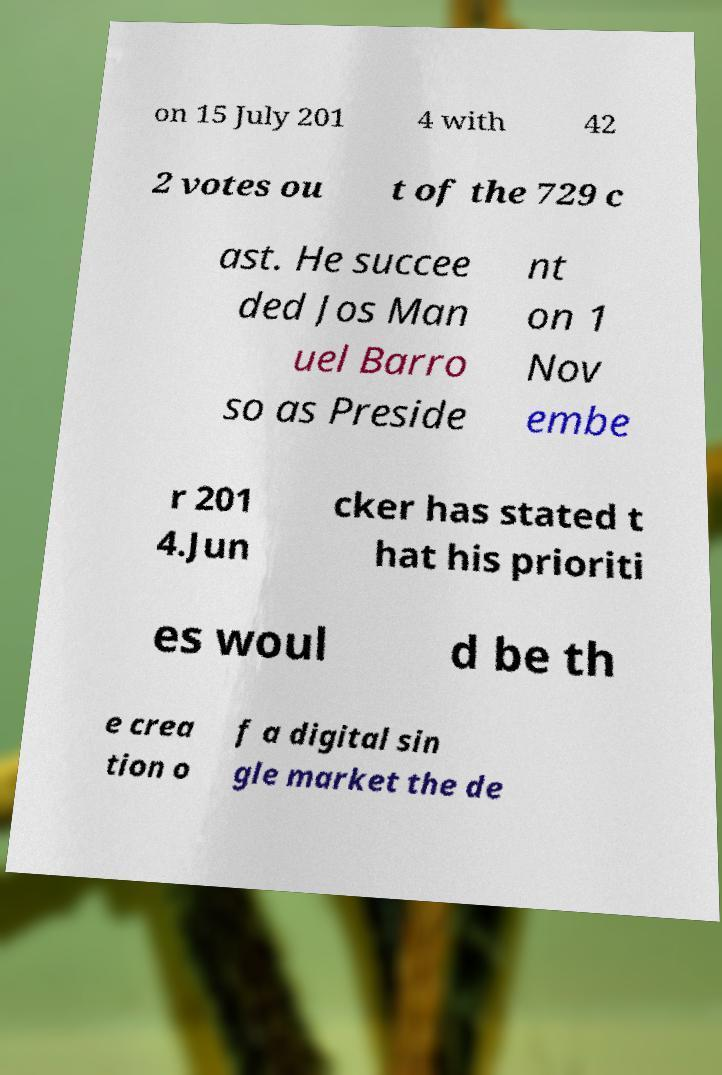Please read and relay the text visible in this image. What does it say? on 15 July 201 4 with 42 2 votes ou t of the 729 c ast. He succee ded Jos Man uel Barro so as Preside nt on 1 Nov embe r 201 4.Jun cker has stated t hat his prioriti es woul d be th e crea tion o f a digital sin gle market the de 